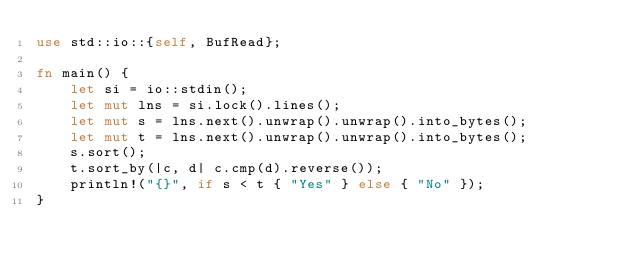<code> <loc_0><loc_0><loc_500><loc_500><_Rust_>use std::io::{self, BufRead};

fn main() {
    let si = io::stdin();
    let mut lns = si.lock().lines();
    let mut s = lns.next().unwrap().unwrap().into_bytes();
    let mut t = lns.next().unwrap().unwrap().into_bytes();
    s.sort();
    t.sort_by(|c, d| c.cmp(d).reverse());
    println!("{}", if s < t { "Yes" } else { "No" });
}</code> 